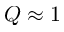Convert formula to latex. <formula><loc_0><loc_0><loc_500><loc_500>Q \approx 1</formula> 